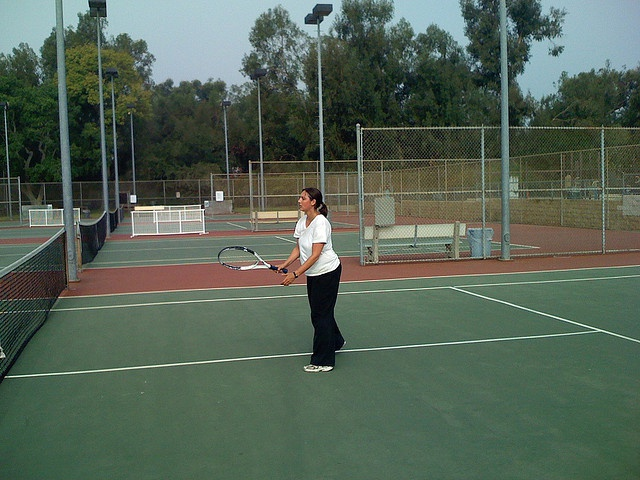Describe the objects in this image and their specific colors. I can see people in lightblue, black, lightgray, brown, and darkgray tones, bench in lightblue, gray, and darkgray tones, tennis racket in lightblue, gray, and darkgray tones, bench in lightblue, tan, and gray tones, and bench in lightblue, beige, gray, and darkgray tones in this image. 